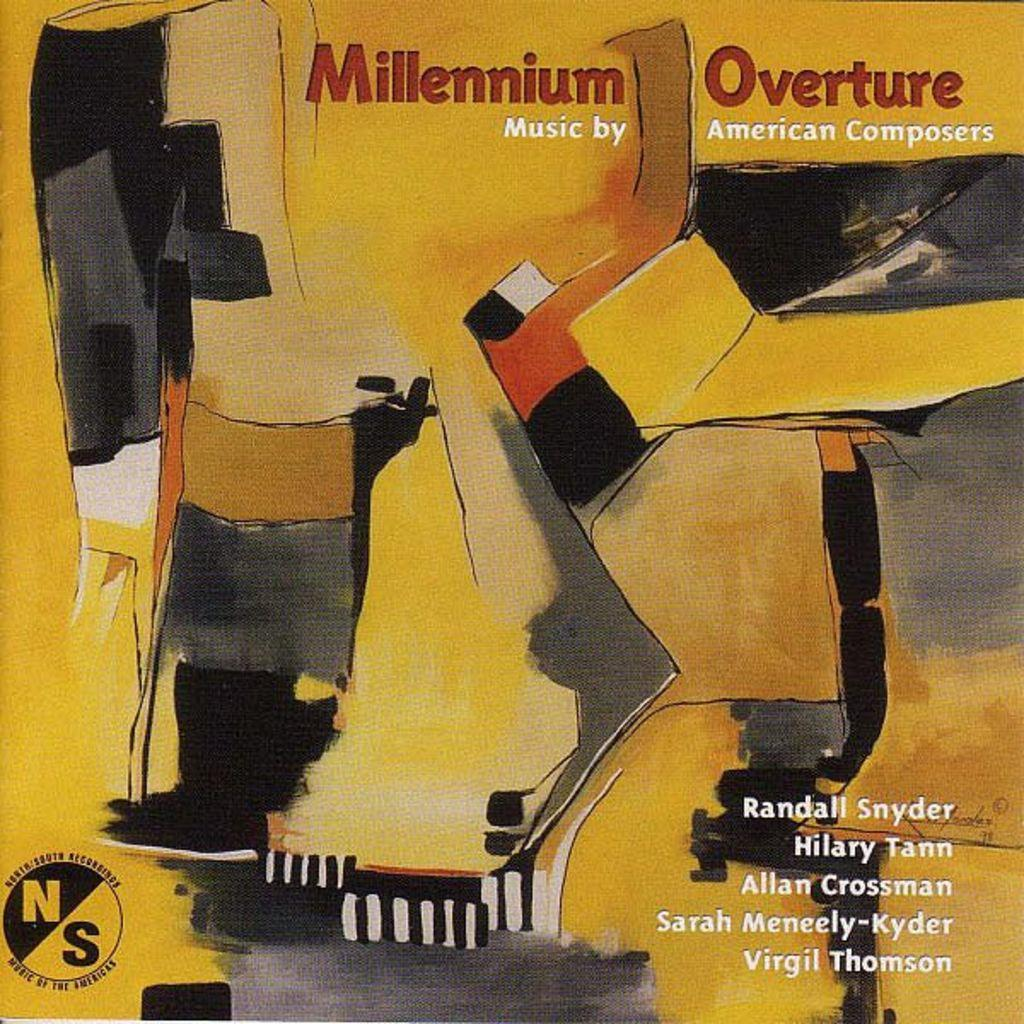Provide a one-sentence caption for the provided image. The album titled Millennium Overture features music by several different American composers. 